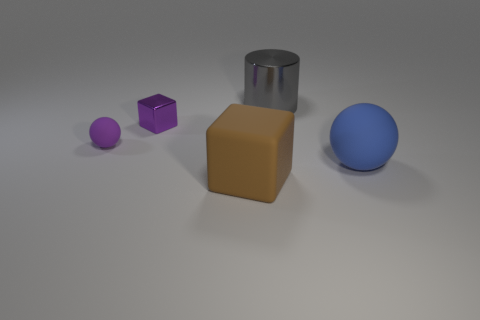What number of objects are either spheres that are on the right side of the gray metal cylinder or matte balls right of the brown thing?
Offer a terse response. 1. Is the gray cylinder made of the same material as the purple sphere behind the blue rubber ball?
Offer a very short reply. No. How many other objects are the same shape as the tiny rubber object?
Keep it short and to the point. 1. What material is the ball to the right of the small thing to the right of the sphere that is behind the blue rubber sphere made of?
Your response must be concise. Rubber. Is the number of large blue balls on the right side of the brown rubber object the same as the number of gray metallic things?
Provide a succinct answer. Yes. Are the cube that is to the left of the large cube and the object that is on the left side of the small purple metallic cube made of the same material?
Provide a succinct answer. No. Is there anything else that has the same material as the big gray cylinder?
Offer a terse response. Yes. Do the tiny object to the left of the tiny purple block and the metallic object behind the small block have the same shape?
Offer a terse response. No. Is the number of blue spheres to the left of the purple metallic thing less than the number of tiny purple spheres?
Keep it short and to the point. Yes. What number of big metal cylinders are the same color as the metal block?
Give a very brief answer. 0. 